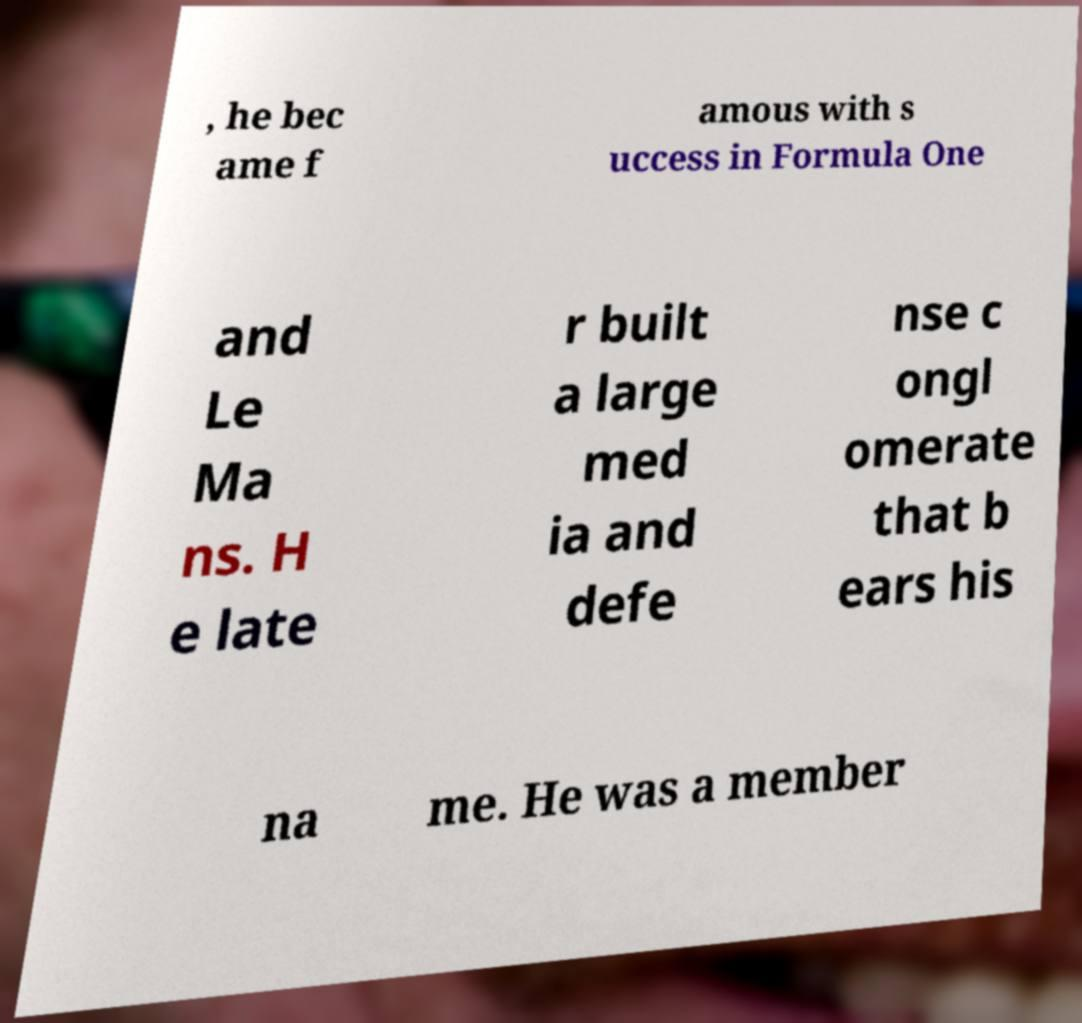Can you read and provide the text displayed in the image?This photo seems to have some interesting text. Can you extract and type it out for me? , he bec ame f amous with s uccess in Formula One and Le Ma ns. H e late r built a large med ia and defe nse c ongl omerate that b ears his na me. He was a member 